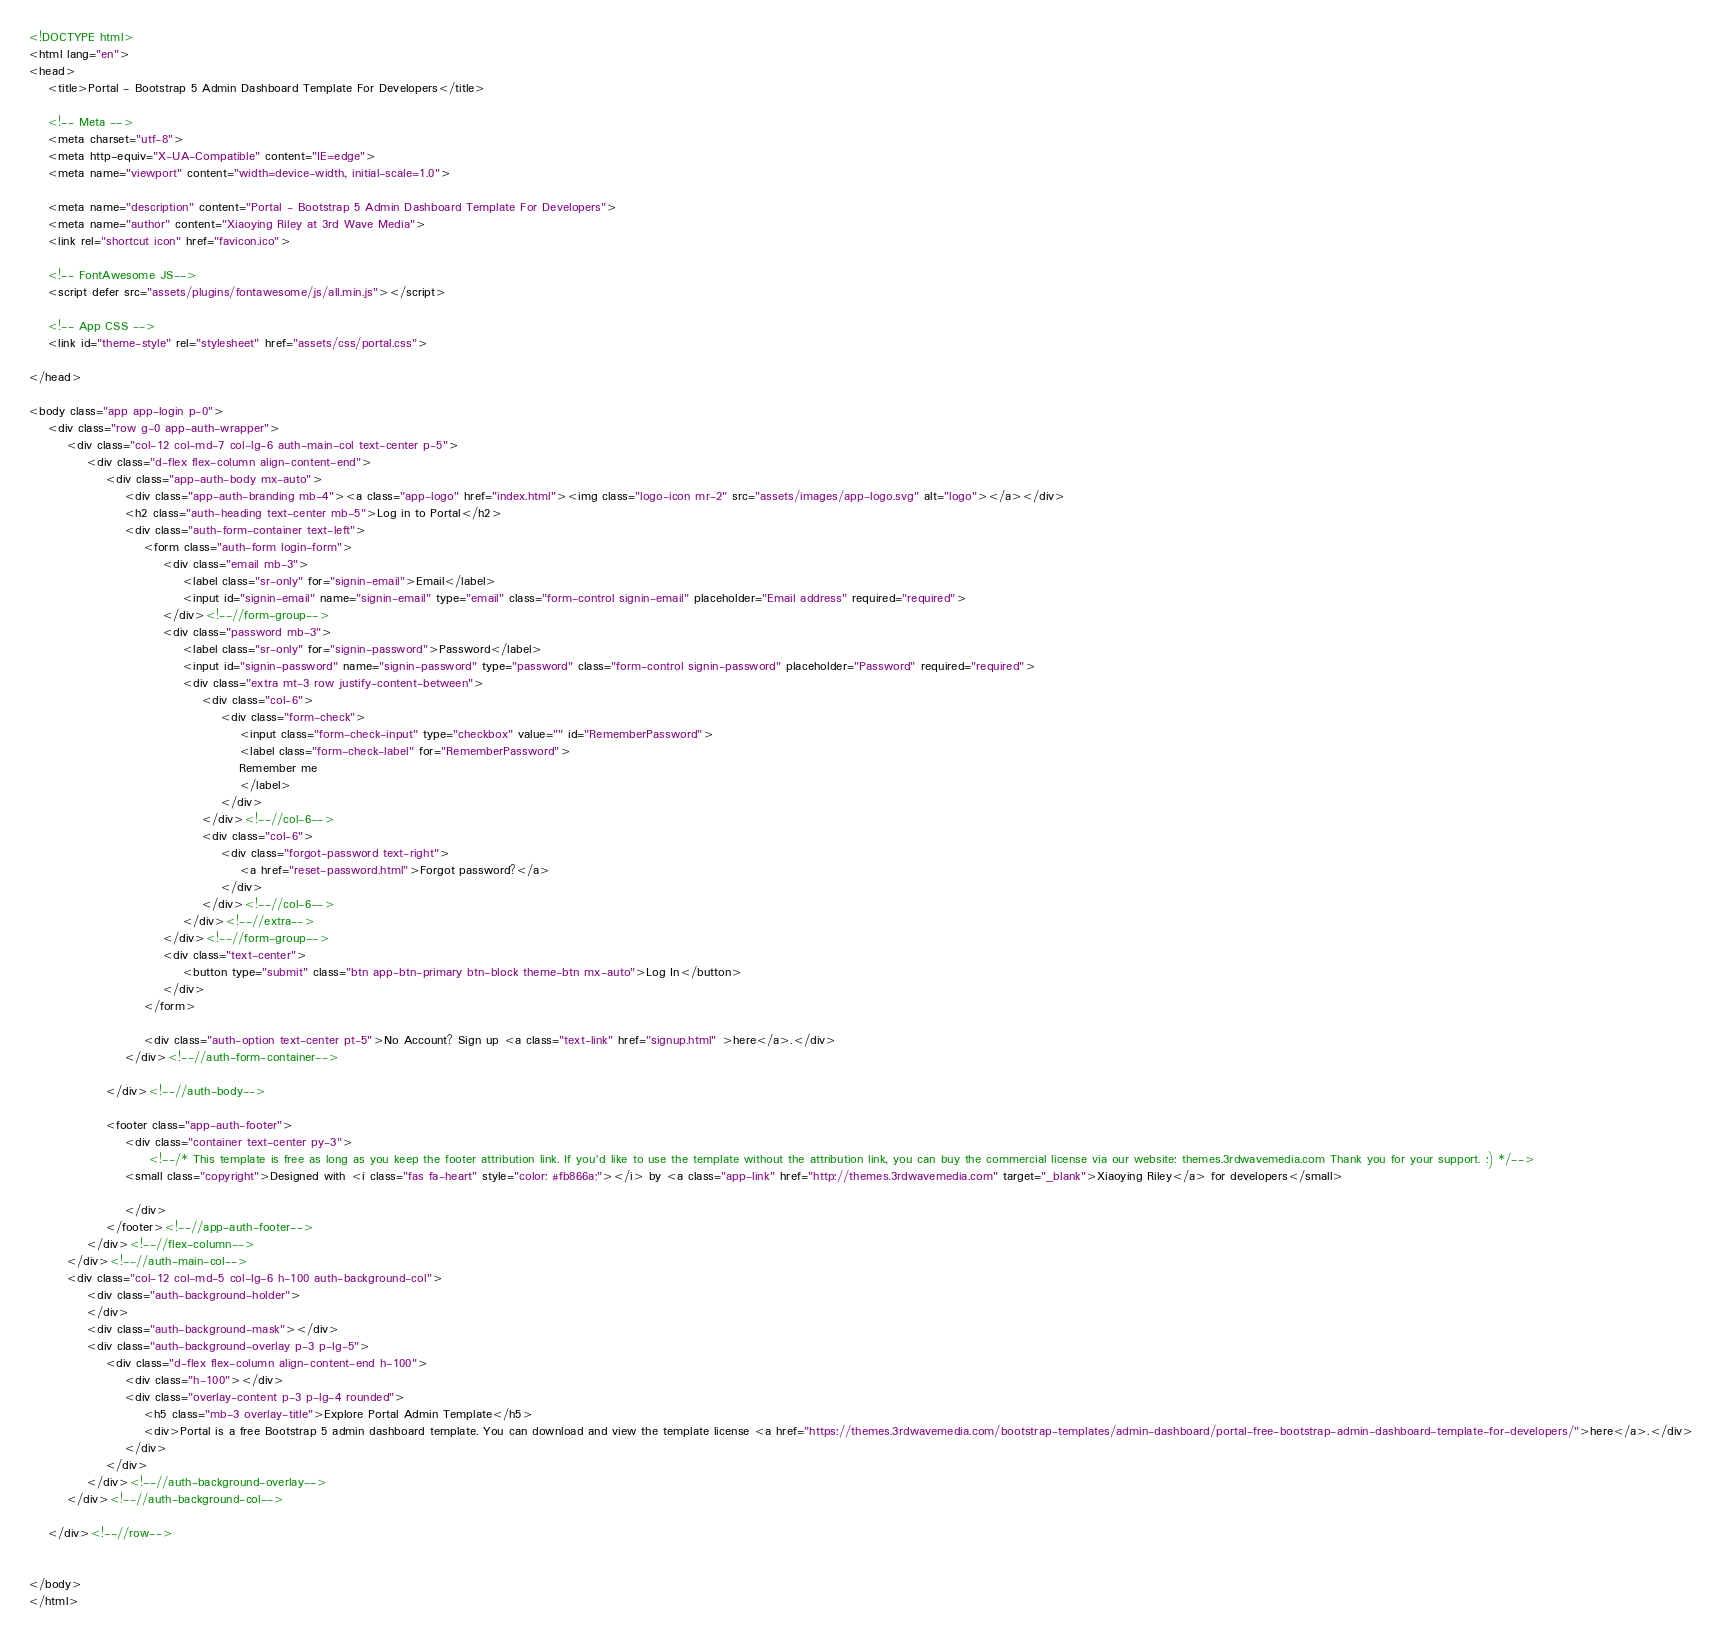Convert code to text. <code><loc_0><loc_0><loc_500><loc_500><_HTML_><!DOCTYPE html>
<html lang="en"> 
<head>
    <title>Portal - Bootstrap 5 Admin Dashboard Template For Developers</title>
    
    <!-- Meta -->
    <meta charset="utf-8">
    <meta http-equiv="X-UA-Compatible" content="IE=edge">
    <meta name="viewport" content="width=device-width, initial-scale=1.0">
    
    <meta name="description" content="Portal - Bootstrap 5 Admin Dashboard Template For Developers">
    <meta name="author" content="Xiaoying Riley at 3rd Wave Media">    
    <link rel="shortcut icon" href="favicon.ico"> 
    
    <!-- FontAwesome JS-->
    <script defer src="assets/plugins/fontawesome/js/all.min.js"></script>
    
    <!-- App CSS -->  
    <link id="theme-style" rel="stylesheet" href="assets/css/portal.css">

</head> 

<body class="app app-login p-0">    	
    <div class="row g-0 app-auth-wrapper">
	    <div class="col-12 col-md-7 col-lg-6 auth-main-col text-center p-5">
		    <div class="d-flex flex-column align-content-end">
			    <div class="app-auth-body mx-auto">	
				    <div class="app-auth-branding mb-4"><a class="app-logo" href="index.html"><img class="logo-icon mr-2" src="assets/images/app-logo.svg" alt="logo"></a></div>
					<h2 class="auth-heading text-center mb-5">Log in to Portal</h2>
			        <div class="auth-form-container text-left">
						<form class="auth-form login-form">         
							<div class="email mb-3">
								<label class="sr-only" for="signin-email">Email</label>
								<input id="signin-email" name="signin-email" type="email" class="form-control signin-email" placeholder="Email address" required="required">
							</div><!--//form-group-->
							<div class="password mb-3">
								<label class="sr-only" for="signin-password">Password</label>
								<input id="signin-password" name="signin-password" type="password" class="form-control signin-password" placeholder="Password" required="required">
								<div class="extra mt-3 row justify-content-between">
									<div class="col-6">
										<div class="form-check">
											<input class="form-check-input" type="checkbox" value="" id="RememberPassword">
											<label class="form-check-label" for="RememberPassword">
											Remember me
											</label>
										</div>
									</div><!--//col-6-->
									<div class="col-6">
										<div class="forgot-password text-right">
											<a href="reset-password.html">Forgot password?</a>
										</div>
									</div><!--//col-6-->
								</div><!--//extra-->
							</div><!--//form-group-->
							<div class="text-center">
								<button type="submit" class="btn app-btn-primary btn-block theme-btn mx-auto">Log In</button>
							</div>
						</form>
						
						<div class="auth-option text-center pt-5">No Account? Sign up <a class="text-link" href="signup.html" >here</a>.</div>
					</div><!--//auth-form-container-->	

			    </div><!--//auth-body-->
		    
			    <footer class="app-auth-footer">
				    <div class="container text-center py-3">
				         <!--/* This template is free as long as you keep the footer attribution link. If you'd like to use the template without the attribution link, you can buy the commercial license via our website: themes.3rdwavemedia.com Thank you for your support. :) */-->
			        <small class="copyright">Designed with <i class="fas fa-heart" style="color: #fb866a;"></i> by <a class="app-link" href="http://themes.3rdwavemedia.com" target="_blank">Xiaoying Riley</a> for developers</small>
				       
				    </div>
			    </footer><!--//app-auth-footer-->	
		    </div><!--//flex-column-->   
	    </div><!--//auth-main-col-->
	    <div class="col-12 col-md-5 col-lg-6 h-100 auth-background-col">
		    <div class="auth-background-holder">
		    </div>
		    <div class="auth-background-mask"></div>
		    <div class="auth-background-overlay p-3 p-lg-5">
			    <div class="d-flex flex-column align-content-end h-100">
				    <div class="h-100"></div>
				    <div class="overlay-content p-3 p-lg-4 rounded">
					    <h5 class="mb-3 overlay-title">Explore Portal Admin Template</h5>
					    <div>Portal is a free Bootstrap 5 admin dashboard template. You can download and view the template license <a href="https://themes.3rdwavemedia.com/bootstrap-templates/admin-dashboard/portal-free-bootstrap-admin-dashboard-template-for-developers/">here</a>.</div>
				    </div>
				</div>
		    </div><!--//auth-background-overlay-->
	    </div><!--//auth-background-col-->
    
    </div><!--//row-->


</body>
</html> 

</code> 